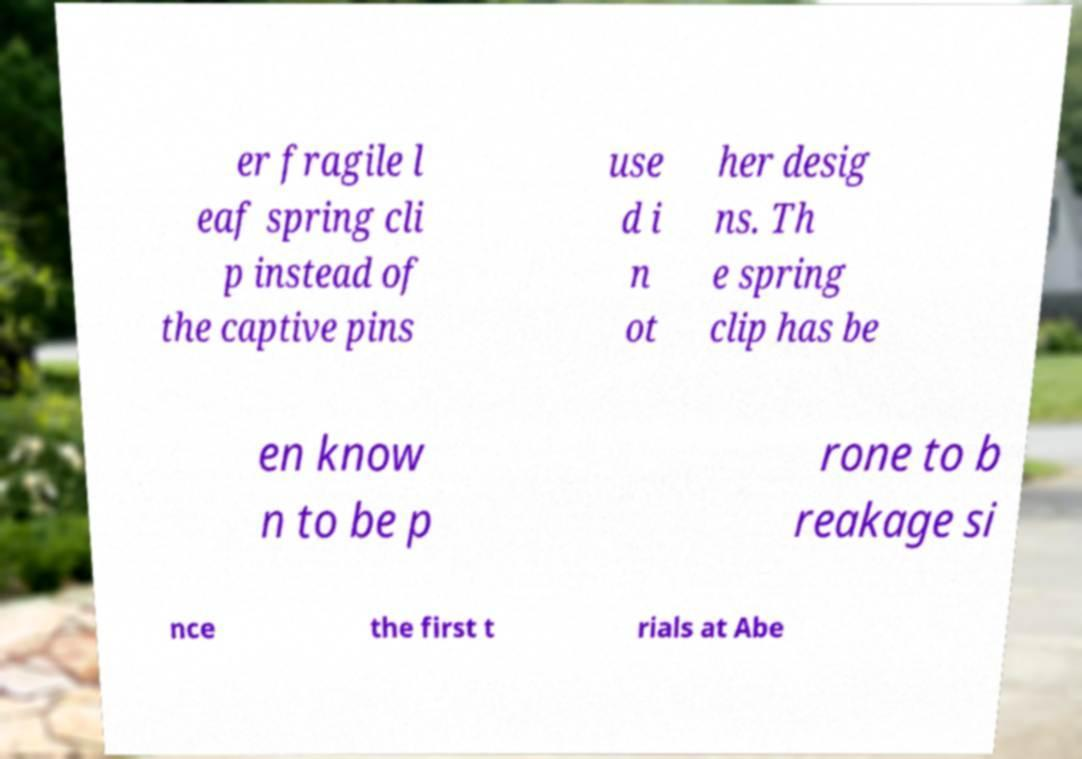Can you accurately transcribe the text from the provided image for me? er fragile l eaf spring cli p instead of the captive pins use d i n ot her desig ns. Th e spring clip has be en know n to be p rone to b reakage si nce the first t rials at Abe 